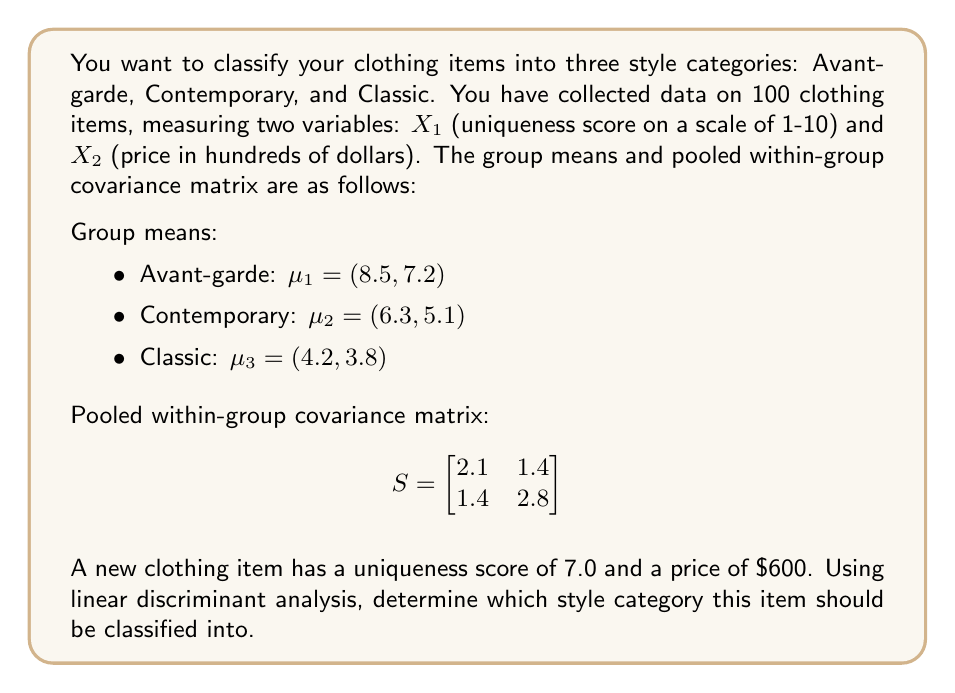Show me your answer to this math problem. To solve this problem using linear discriminant analysis, we'll follow these steps:

1. Calculate the inverse of the pooled within-group covariance matrix $S^{-1}$.
2. Compute the linear discriminant functions for each group.
3. Evaluate the discriminant functions for the new item and classify it into the group with the highest score.

Step 1: Calculate $S^{-1}$
$$S^{-1} = \frac{1}{2.1 \cdot 2.8 - 1.4^2} \begin{bmatrix} 2.8 & -1.4 \\ -1.4 & 2.1 \end{bmatrix} = \begin{bmatrix} 0.5833 & -0.2917 \\ -0.2917 & 0.4375 \end{bmatrix}$$

Step 2: Compute linear discriminant functions
The linear discriminant function for group $i$ is given by:
$$d_i(x) = \mu_i^T S^{-1} x - \frac{1}{2} \mu_i^T S^{-1} \mu_i$$

For Avant-garde (Group 1):
$$d_1(x) = [8.5 \quad 7.2] \begin{bmatrix} 0.5833 & -0.2917 \\ -0.2917 & 0.4375 \end{bmatrix} \begin{bmatrix} x_1 \\ x_2 \end{bmatrix} - \frac{1}{2} [8.5 \quad 7.2] \begin{bmatrix} 0.5833 & -0.2917 \\ -0.2917 & 0.4375 \end{bmatrix} \begin{bmatrix} 8.5 \\ 7.2 \end{bmatrix}$$
$$d_1(x) = 3.3958x_1 + 1.8125x_2 - 24.8438$$

Similarly, for Contemporary (Group 2):
$$d_2(x) = 2.5208x_1 + 1.3438x_2 - 13.7109$$

And for Classic (Group 3):
$$d_3(x) = 1.6875x_1 + 0.9063x_2 - 6.1641$$

Step 3: Evaluate discriminant functions for the new item $(x_1 = 7.0, x_2 = 6.0)$

For Avant-garde:
$$d_1(7.0, 6.0) = 3.3958 \cdot 7.0 + 1.8125 \cdot 6.0 - 24.8438 = 10.2969$$

For Contemporary:
$$d_2(7.0, 6.0) = 2.5208 \cdot 7.0 + 1.3438 \cdot 6.0 - 13.7109 = 11.0547$$

For Classic:
$$d_3(7.0, 6.0) = 1.6875 \cdot 7.0 + 0.9063 \cdot 6.0 - 6.1641 = 10.1172$$

The highest score is for the Contemporary group (11.0547), so the new item should be classified as Contemporary.
Answer: The new clothing item with a uniqueness score of 7.0 and a price of $600 should be classified as Contemporary. 